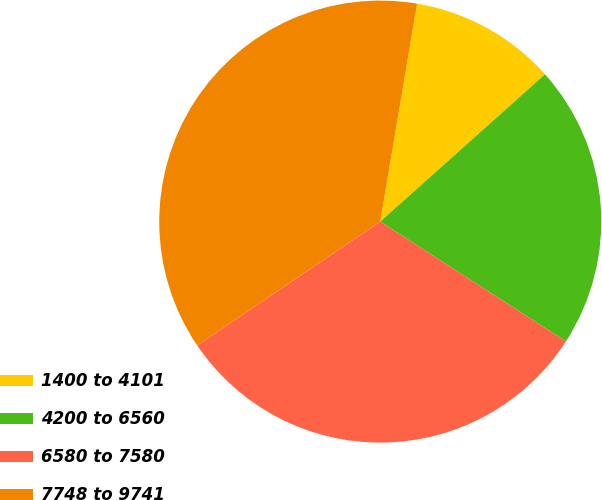<chart> <loc_0><loc_0><loc_500><loc_500><pie_chart><fcel>1400 to 4101<fcel>4200 to 6560<fcel>6580 to 7580<fcel>7748 to 9741<nl><fcel>10.73%<fcel>20.73%<fcel>31.41%<fcel>37.14%<nl></chart> 